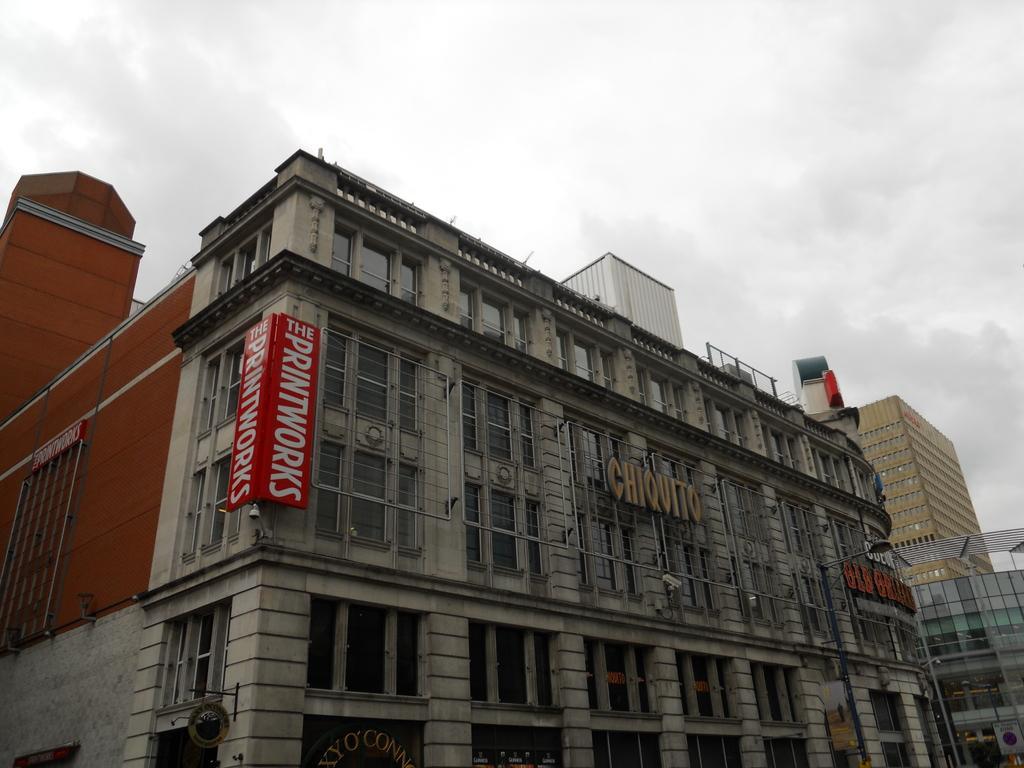Describe this image in one or two sentences. In front of the picture, we see a building in grey and brown color. It has many windows. On the left side, we see a board in red color with some text written on it. At the bottom, we see a board in black color with some text written on it. In the middle of the picture, we see some text written on the building. There are buildings in the background. At the top, we see the sky. 